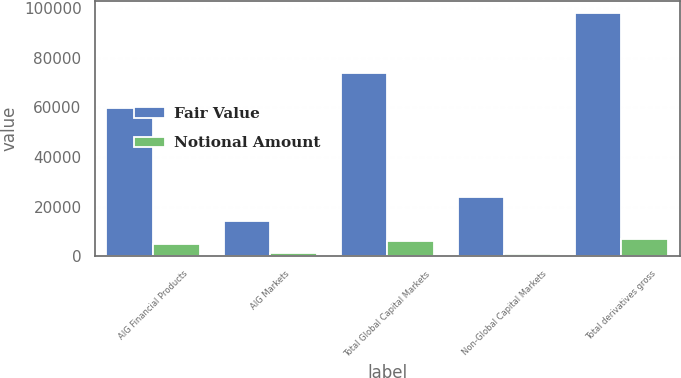Convert chart to OTSL. <chart><loc_0><loc_0><loc_500><loc_500><stacked_bar_chart><ecel><fcel>AIG Financial Products<fcel>AIG Markets<fcel>Total Global Capital Markets<fcel>Non-Global Capital Markets<fcel>Total derivatives gross<nl><fcel>Fair Value<fcel>59854<fcel>14028<fcel>73882<fcel>24040<fcel>97922<nl><fcel>Notional Amount<fcel>4725<fcel>1308<fcel>6033<fcel>1014<fcel>7047<nl></chart> 